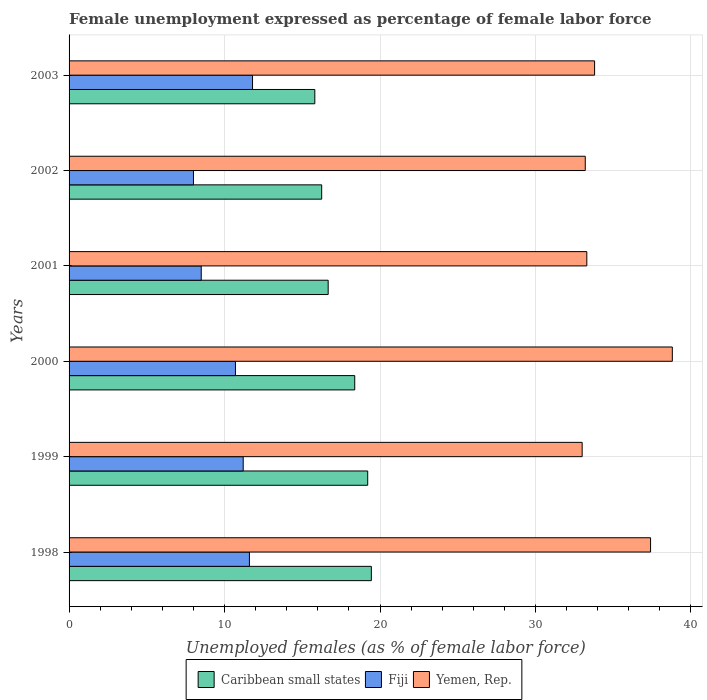How many different coloured bars are there?
Your answer should be compact. 3. How many groups of bars are there?
Provide a succinct answer. 6. Are the number of bars on each tick of the Y-axis equal?
Provide a short and direct response. Yes. In how many cases, is the number of bars for a given year not equal to the number of legend labels?
Offer a very short reply. 0. What is the unemployment in females in in Fiji in 2003?
Your answer should be very brief. 11.8. Across all years, what is the maximum unemployment in females in in Caribbean small states?
Offer a very short reply. 19.44. Across all years, what is the minimum unemployment in females in in Fiji?
Your answer should be compact. 8. In which year was the unemployment in females in in Fiji maximum?
Make the answer very short. 2003. What is the total unemployment in females in in Caribbean small states in the graph?
Your answer should be very brief. 105.74. What is the difference between the unemployment in females in in Yemen, Rep. in 1998 and that in 2003?
Your response must be concise. 3.6. What is the difference between the unemployment in females in in Yemen, Rep. in 1998 and the unemployment in females in in Fiji in 2003?
Offer a very short reply. 25.6. What is the average unemployment in females in in Yemen, Rep. per year?
Ensure brevity in your answer.  34.92. In the year 2000, what is the difference between the unemployment in females in in Caribbean small states and unemployment in females in in Fiji?
Your response must be concise. 7.67. In how many years, is the unemployment in females in in Fiji greater than 18 %?
Keep it short and to the point. 0. What is the ratio of the unemployment in females in in Fiji in 1999 to that in 2003?
Your answer should be very brief. 0.95. Is the unemployment in females in in Fiji in 2002 less than that in 2003?
Provide a succinct answer. Yes. What is the difference between the highest and the second highest unemployment in females in in Yemen, Rep.?
Your answer should be very brief. 1.4. What is the difference between the highest and the lowest unemployment in females in in Fiji?
Offer a very short reply. 3.8. Is the sum of the unemployment in females in in Fiji in 2001 and 2003 greater than the maximum unemployment in females in in Caribbean small states across all years?
Your answer should be very brief. Yes. What does the 3rd bar from the top in 2001 represents?
Keep it short and to the point. Caribbean small states. What does the 3rd bar from the bottom in 2002 represents?
Ensure brevity in your answer.  Yemen, Rep. Is it the case that in every year, the sum of the unemployment in females in in Caribbean small states and unemployment in females in in Fiji is greater than the unemployment in females in in Yemen, Rep.?
Provide a succinct answer. No. Are all the bars in the graph horizontal?
Ensure brevity in your answer.  Yes. What is the difference between two consecutive major ticks on the X-axis?
Make the answer very short. 10. Are the values on the major ticks of X-axis written in scientific E-notation?
Ensure brevity in your answer.  No. Does the graph contain grids?
Your answer should be compact. Yes. Where does the legend appear in the graph?
Your response must be concise. Bottom center. How many legend labels are there?
Offer a terse response. 3. What is the title of the graph?
Provide a succinct answer. Female unemployment expressed as percentage of female labor force. Does "Azerbaijan" appear as one of the legend labels in the graph?
Ensure brevity in your answer.  No. What is the label or title of the X-axis?
Offer a very short reply. Unemployed females (as % of female labor force). What is the label or title of the Y-axis?
Provide a succinct answer. Years. What is the Unemployed females (as % of female labor force) in Caribbean small states in 1998?
Make the answer very short. 19.44. What is the Unemployed females (as % of female labor force) of Fiji in 1998?
Make the answer very short. 11.6. What is the Unemployed females (as % of female labor force) in Yemen, Rep. in 1998?
Give a very brief answer. 37.4. What is the Unemployed females (as % of female labor force) in Caribbean small states in 1999?
Provide a succinct answer. 19.21. What is the Unemployed females (as % of female labor force) of Fiji in 1999?
Your answer should be compact. 11.2. What is the Unemployed females (as % of female labor force) in Yemen, Rep. in 1999?
Make the answer very short. 33. What is the Unemployed females (as % of female labor force) in Caribbean small states in 2000?
Provide a short and direct response. 18.37. What is the Unemployed females (as % of female labor force) of Fiji in 2000?
Offer a very short reply. 10.7. What is the Unemployed females (as % of female labor force) of Yemen, Rep. in 2000?
Your answer should be very brief. 38.8. What is the Unemployed females (as % of female labor force) of Caribbean small states in 2001?
Keep it short and to the point. 16.66. What is the Unemployed females (as % of female labor force) of Fiji in 2001?
Give a very brief answer. 8.5. What is the Unemployed females (as % of female labor force) in Yemen, Rep. in 2001?
Make the answer very short. 33.3. What is the Unemployed females (as % of female labor force) of Caribbean small states in 2002?
Keep it short and to the point. 16.25. What is the Unemployed females (as % of female labor force) in Fiji in 2002?
Your answer should be compact. 8. What is the Unemployed females (as % of female labor force) of Yemen, Rep. in 2002?
Your answer should be very brief. 33.2. What is the Unemployed females (as % of female labor force) of Caribbean small states in 2003?
Offer a very short reply. 15.81. What is the Unemployed females (as % of female labor force) in Fiji in 2003?
Your answer should be compact. 11.8. What is the Unemployed females (as % of female labor force) in Yemen, Rep. in 2003?
Give a very brief answer. 33.8. Across all years, what is the maximum Unemployed females (as % of female labor force) in Caribbean small states?
Make the answer very short. 19.44. Across all years, what is the maximum Unemployed females (as % of female labor force) in Fiji?
Offer a terse response. 11.8. Across all years, what is the maximum Unemployed females (as % of female labor force) in Yemen, Rep.?
Make the answer very short. 38.8. Across all years, what is the minimum Unemployed females (as % of female labor force) in Caribbean small states?
Your answer should be very brief. 15.81. Across all years, what is the minimum Unemployed females (as % of female labor force) of Fiji?
Keep it short and to the point. 8. Across all years, what is the minimum Unemployed females (as % of female labor force) of Yemen, Rep.?
Your response must be concise. 33. What is the total Unemployed females (as % of female labor force) of Caribbean small states in the graph?
Your answer should be very brief. 105.74. What is the total Unemployed females (as % of female labor force) in Fiji in the graph?
Your answer should be very brief. 61.8. What is the total Unemployed females (as % of female labor force) in Yemen, Rep. in the graph?
Provide a short and direct response. 209.5. What is the difference between the Unemployed females (as % of female labor force) of Caribbean small states in 1998 and that in 1999?
Offer a very short reply. 0.23. What is the difference between the Unemployed females (as % of female labor force) of Fiji in 1998 and that in 1999?
Offer a very short reply. 0.4. What is the difference between the Unemployed females (as % of female labor force) of Caribbean small states in 1998 and that in 2000?
Your answer should be compact. 1.07. What is the difference between the Unemployed females (as % of female labor force) of Fiji in 1998 and that in 2000?
Your response must be concise. 0.9. What is the difference between the Unemployed females (as % of female labor force) in Caribbean small states in 1998 and that in 2001?
Offer a terse response. 2.78. What is the difference between the Unemployed females (as % of female labor force) of Yemen, Rep. in 1998 and that in 2001?
Offer a terse response. 4.1. What is the difference between the Unemployed females (as % of female labor force) in Caribbean small states in 1998 and that in 2002?
Your response must be concise. 3.19. What is the difference between the Unemployed females (as % of female labor force) in Yemen, Rep. in 1998 and that in 2002?
Ensure brevity in your answer.  4.2. What is the difference between the Unemployed females (as % of female labor force) in Caribbean small states in 1998 and that in 2003?
Offer a terse response. 3.64. What is the difference between the Unemployed females (as % of female labor force) of Caribbean small states in 1999 and that in 2000?
Keep it short and to the point. 0.83. What is the difference between the Unemployed females (as % of female labor force) of Fiji in 1999 and that in 2000?
Make the answer very short. 0.5. What is the difference between the Unemployed females (as % of female labor force) in Caribbean small states in 1999 and that in 2001?
Keep it short and to the point. 2.54. What is the difference between the Unemployed females (as % of female labor force) in Yemen, Rep. in 1999 and that in 2001?
Provide a succinct answer. -0.3. What is the difference between the Unemployed females (as % of female labor force) in Caribbean small states in 1999 and that in 2002?
Offer a very short reply. 2.96. What is the difference between the Unemployed females (as % of female labor force) of Caribbean small states in 1999 and that in 2003?
Your response must be concise. 3.4. What is the difference between the Unemployed females (as % of female labor force) of Caribbean small states in 2000 and that in 2001?
Ensure brevity in your answer.  1.71. What is the difference between the Unemployed females (as % of female labor force) in Caribbean small states in 2000 and that in 2002?
Keep it short and to the point. 2.13. What is the difference between the Unemployed females (as % of female labor force) in Caribbean small states in 2000 and that in 2003?
Your answer should be compact. 2.57. What is the difference between the Unemployed females (as % of female labor force) in Yemen, Rep. in 2000 and that in 2003?
Your response must be concise. 5. What is the difference between the Unemployed females (as % of female labor force) of Caribbean small states in 2001 and that in 2002?
Ensure brevity in your answer.  0.42. What is the difference between the Unemployed females (as % of female labor force) in Yemen, Rep. in 2001 and that in 2002?
Keep it short and to the point. 0.1. What is the difference between the Unemployed females (as % of female labor force) in Caribbean small states in 2001 and that in 2003?
Keep it short and to the point. 0.86. What is the difference between the Unemployed females (as % of female labor force) in Fiji in 2001 and that in 2003?
Offer a terse response. -3.3. What is the difference between the Unemployed females (as % of female labor force) of Caribbean small states in 2002 and that in 2003?
Give a very brief answer. 0.44. What is the difference between the Unemployed females (as % of female labor force) of Caribbean small states in 1998 and the Unemployed females (as % of female labor force) of Fiji in 1999?
Provide a succinct answer. 8.24. What is the difference between the Unemployed females (as % of female labor force) in Caribbean small states in 1998 and the Unemployed females (as % of female labor force) in Yemen, Rep. in 1999?
Your response must be concise. -13.56. What is the difference between the Unemployed females (as % of female labor force) of Fiji in 1998 and the Unemployed females (as % of female labor force) of Yemen, Rep. in 1999?
Provide a succinct answer. -21.4. What is the difference between the Unemployed females (as % of female labor force) in Caribbean small states in 1998 and the Unemployed females (as % of female labor force) in Fiji in 2000?
Offer a very short reply. 8.74. What is the difference between the Unemployed females (as % of female labor force) in Caribbean small states in 1998 and the Unemployed females (as % of female labor force) in Yemen, Rep. in 2000?
Keep it short and to the point. -19.36. What is the difference between the Unemployed females (as % of female labor force) of Fiji in 1998 and the Unemployed females (as % of female labor force) of Yemen, Rep. in 2000?
Your answer should be very brief. -27.2. What is the difference between the Unemployed females (as % of female labor force) of Caribbean small states in 1998 and the Unemployed females (as % of female labor force) of Fiji in 2001?
Your response must be concise. 10.94. What is the difference between the Unemployed females (as % of female labor force) in Caribbean small states in 1998 and the Unemployed females (as % of female labor force) in Yemen, Rep. in 2001?
Your answer should be very brief. -13.86. What is the difference between the Unemployed females (as % of female labor force) of Fiji in 1998 and the Unemployed females (as % of female labor force) of Yemen, Rep. in 2001?
Make the answer very short. -21.7. What is the difference between the Unemployed females (as % of female labor force) of Caribbean small states in 1998 and the Unemployed females (as % of female labor force) of Fiji in 2002?
Provide a succinct answer. 11.44. What is the difference between the Unemployed females (as % of female labor force) in Caribbean small states in 1998 and the Unemployed females (as % of female labor force) in Yemen, Rep. in 2002?
Offer a very short reply. -13.76. What is the difference between the Unemployed females (as % of female labor force) in Fiji in 1998 and the Unemployed females (as % of female labor force) in Yemen, Rep. in 2002?
Give a very brief answer. -21.6. What is the difference between the Unemployed females (as % of female labor force) in Caribbean small states in 1998 and the Unemployed females (as % of female labor force) in Fiji in 2003?
Provide a short and direct response. 7.64. What is the difference between the Unemployed females (as % of female labor force) of Caribbean small states in 1998 and the Unemployed females (as % of female labor force) of Yemen, Rep. in 2003?
Provide a short and direct response. -14.36. What is the difference between the Unemployed females (as % of female labor force) of Fiji in 1998 and the Unemployed females (as % of female labor force) of Yemen, Rep. in 2003?
Give a very brief answer. -22.2. What is the difference between the Unemployed females (as % of female labor force) of Caribbean small states in 1999 and the Unemployed females (as % of female labor force) of Fiji in 2000?
Provide a short and direct response. 8.51. What is the difference between the Unemployed females (as % of female labor force) of Caribbean small states in 1999 and the Unemployed females (as % of female labor force) of Yemen, Rep. in 2000?
Ensure brevity in your answer.  -19.59. What is the difference between the Unemployed females (as % of female labor force) of Fiji in 1999 and the Unemployed females (as % of female labor force) of Yemen, Rep. in 2000?
Ensure brevity in your answer.  -27.6. What is the difference between the Unemployed females (as % of female labor force) in Caribbean small states in 1999 and the Unemployed females (as % of female labor force) in Fiji in 2001?
Ensure brevity in your answer.  10.71. What is the difference between the Unemployed females (as % of female labor force) of Caribbean small states in 1999 and the Unemployed females (as % of female labor force) of Yemen, Rep. in 2001?
Your response must be concise. -14.09. What is the difference between the Unemployed females (as % of female labor force) of Fiji in 1999 and the Unemployed females (as % of female labor force) of Yemen, Rep. in 2001?
Offer a terse response. -22.1. What is the difference between the Unemployed females (as % of female labor force) of Caribbean small states in 1999 and the Unemployed females (as % of female labor force) of Fiji in 2002?
Give a very brief answer. 11.21. What is the difference between the Unemployed females (as % of female labor force) of Caribbean small states in 1999 and the Unemployed females (as % of female labor force) of Yemen, Rep. in 2002?
Make the answer very short. -13.99. What is the difference between the Unemployed females (as % of female labor force) in Fiji in 1999 and the Unemployed females (as % of female labor force) in Yemen, Rep. in 2002?
Give a very brief answer. -22. What is the difference between the Unemployed females (as % of female labor force) in Caribbean small states in 1999 and the Unemployed females (as % of female labor force) in Fiji in 2003?
Your answer should be compact. 7.41. What is the difference between the Unemployed females (as % of female labor force) of Caribbean small states in 1999 and the Unemployed females (as % of female labor force) of Yemen, Rep. in 2003?
Your answer should be compact. -14.59. What is the difference between the Unemployed females (as % of female labor force) in Fiji in 1999 and the Unemployed females (as % of female labor force) in Yemen, Rep. in 2003?
Your answer should be compact. -22.6. What is the difference between the Unemployed females (as % of female labor force) of Caribbean small states in 2000 and the Unemployed females (as % of female labor force) of Fiji in 2001?
Offer a very short reply. 9.87. What is the difference between the Unemployed females (as % of female labor force) in Caribbean small states in 2000 and the Unemployed females (as % of female labor force) in Yemen, Rep. in 2001?
Your response must be concise. -14.93. What is the difference between the Unemployed females (as % of female labor force) in Fiji in 2000 and the Unemployed females (as % of female labor force) in Yemen, Rep. in 2001?
Provide a short and direct response. -22.6. What is the difference between the Unemployed females (as % of female labor force) of Caribbean small states in 2000 and the Unemployed females (as % of female labor force) of Fiji in 2002?
Provide a succinct answer. 10.37. What is the difference between the Unemployed females (as % of female labor force) of Caribbean small states in 2000 and the Unemployed females (as % of female labor force) of Yemen, Rep. in 2002?
Keep it short and to the point. -14.83. What is the difference between the Unemployed females (as % of female labor force) of Fiji in 2000 and the Unemployed females (as % of female labor force) of Yemen, Rep. in 2002?
Make the answer very short. -22.5. What is the difference between the Unemployed females (as % of female labor force) in Caribbean small states in 2000 and the Unemployed females (as % of female labor force) in Fiji in 2003?
Your answer should be very brief. 6.57. What is the difference between the Unemployed females (as % of female labor force) of Caribbean small states in 2000 and the Unemployed females (as % of female labor force) of Yemen, Rep. in 2003?
Give a very brief answer. -15.43. What is the difference between the Unemployed females (as % of female labor force) of Fiji in 2000 and the Unemployed females (as % of female labor force) of Yemen, Rep. in 2003?
Your response must be concise. -23.1. What is the difference between the Unemployed females (as % of female labor force) of Caribbean small states in 2001 and the Unemployed females (as % of female labor force) of Fiji in 2002?
Make the answer very short. 8.66. What is the difference between the Unemployed females (as % of female labor force) in Caribbean small states in 2001 and the Unemployed females (as % of female labor force) in Yemen, Rep. in 2002?
Offer a very short reply. -16.54. What is the difference between the Unemployed females (as % of female labor force) of Fiji in 2001 and the Unemployed females (as % of female labor force) of Yemen, Rep. in 2002?
Your answer should be very brief. -24.7. What is the difference between the Unemployed females (as % of female labor force) of Caribbean small states in 2001 and the Unemployed females (as % of female labor force) of Fiji in 2003?
Your response must be concise. 4.86. What is the difference between the Unemployed females (as % of female labor force) in Caribbean small states in 2001 and the Unemployed females (as % of female labor force) in Yemen, Rep. in 2003?
Your response must be concise. -17.14. What is the difference between the Unemployed females (as % of female labor force) in Fiji in 2001 and the Unemployed females (as % of female labor force) in Yemen, Rep. in 2003?
Offer a very short reply. -25.3. What is the difference between the Unemployed females (as % of female labor force) of Caribbean small states in 2002 and the Unemployed females (as % of female labor force) of Fiji in 2003?
Provide a short and direct response. 4.45. What is the difference between the Unemployed females (as % of female labor force) in Caribbean small states in 2002 and the Unemployed females (as % of female labor force) in Yemen, Rep. in 2003?
Your response must be concise. -17.55. What is the difference between the Unemployed females (as % of female labor force) of Fiji in 2002 and the Unemployed females (as % of female labor force) of Yemen, Rep. in 2003?
Ensure brevity in your answer.  -25.8. What is the average Unemployed females (as % of female labor force) of Caribbean small states per year?
Ensure brevity in your answer.  17.62. What is the average Unemployed females (as % of female labor force) in Yemen, Rep. per year?
Your answer should be compact. 34.92. In the year 1998, what is the difference between the Unemployed females (as % of female labor force) of Caribbean small states and Unemployed females (as % of female labor force) of Fiji?
Provide a short and direct response. 7.84. In the year 1998, what is the difference between the Unemployed females (as % of female labor force) in Caribbean small states and Unemployed females (as % of female labor force) in Yemen, Rep.?
Offer a very short reply. -17.96. In the year 1998, what is the difference between the Unemployed females (as % of female labor force) in Fiji and Unemployed females (as % of female labor force) in Yemen, Rep.?
Provide a short and direct response. -25.8. In the year 1999, what is the difference between the Unemployed females (as % of female labor force) in Caribbean small states and Unemployed females (as % of female labor force) in Fiji?
Keep it short and to the point. 8.01. In the year 1999, what is the difference between the Unemployed females (as % of female labor force) in Caribbean small states and Unemployed females (as % of female labor force) in Yemen, Rep.?
Ensure brevity in your answer.  -13.79. In the year 1999, what is the difference between the Unemployed females (as % of female labor force) in Fiji and Unemployed females (as % of female labor force) in Yemen, Rep.?
Your answer should be compact. -21.8. In the year 2000, what is the difference between the Unemployed females (as % of female labor force) in Caribbean small states and Unemployed females (as % of female labor force) in Fiji?
Give a very brief answer. 7.67. In the year 2000, what is the difference between the Unemployed females (as % of female labor force) in Caribbean small states and Unemployed females (as % of female labor force) in Yemen, Rep.?
Provide a succinct answer. -20.43. In the year 2000, what is the difference between the Unemployed females (as % of female labor force) of Fiji and Unemployed females (as % of female labor force) of Yemen, Rep.?
Provide a short and direct response. -28.1. In the year 2001, what is the difference between the Unemployed females (as % of female labor force) in Caribbean small states and Unemployed females (as % of female labor force) in Fiji?
Your response must be concise. 8.16. In the year 2001, what is the difference between the Unemployed females (as % of female labor force) in Caribbean small states and Unemployed females (as % of female labor force) in Yemen, Rep.?
Your response must be concise. -16.64. In the year 2001, what is the difference between the Unemployed females (as % of female labor force) in Fiji and Unemployed females (as % of female labor force) in Yemen, Rep.?
Provide a succinct answer. -24.8. In the year 2002, what is the difference between the Unemployed females (as % of female labor force) of Caribbean small states and Unemployed females (as % of female labor force) of Fiji?
Your answer should be very brief. 8.25. In the year 2002, what is the difference between the Unemployed females (as % of female labor force) in Caribbean small states and Unemployed females (as % of female labor force) in Yemen, Rep.?
Your answer should be very brief. -16.95. In the year 2002, what is the difference between the Unemployed females (as % of female labor force) in Fiji and Unemployed females (as % of female labor force) in Yemen, Rep.?
Make the answer very short. -25.2. In the year 2003, what is the difference between the Unemployed females (as % of female labor force) in Caribbean small states and Unemployed females (as % of female labor force) in Fiji?
Your answer should be very brief. 4.01. In the year 2003, what is the difference between the Unemployed females (as % of female labor force) of Caribbean small states and Unemployed females (as % of female labor force) of Yemen, Rep.?
Offer a very short reply. -17.99. What is the ratio of the Unemployed females (as % of female labor force) of Caribbean small states in 1998 to that in 1999?
Keep it short and to the point. 1.01. What is the ratio of the Unemployed females (as % of female labor force) of Fiji in 1998 to that in 1999?
Offer a terse response. 1.04. What is the ratio of the Unemployed females (as % of female labor force) of Yemen, Rep. in 1998 to that in 1999?
Give a very brief answer. 1.13. What is the ratio of the Unemployed females (as % of female labor force) of Caribbean small states in 1998 to that in 2000?
Give a very brief answer. 1.06. What is the ratio of the Unemployed females (as % of female labor force) of Fiji in 1998 to that in 2000?
Your answer should be very brief. 1.08. What is the ratio of the Unemployed females (as % of female labor force) in Yemen, Rep. in 1998 to that in 2000?
Keep it short and to the point. 0.96. What is the ratio of the Unemployed females (as % of female labor force) of Caribbean small states in 1998 to that in 2001?
Your response must be concise. 1.17. What is the ratio of the Unemployed females (as % of female labor force) in Fiji in 1998 to that in 2001?
Your response must be concise. 1.36. What is the ratio of the Unemployed females (as % of female labor force) of Yemen, Rep. in 1998 to that in 2001?
Offer a terse response. 1.12. What is the ratio of the Unemployed females (as % of female labor force) in Caribbean small states in 1998 to that in 2002?
Provide a short and direct response. 1.2. What is the ratio of the Unemployed females (as % of female labor force) of Fiji in 1998 to that in 2002?
Make the answer very short. 1.45. What is the ratio of the Unemployed females (as % of female labor force) of Yemen, Rep. in 1998 to that in 2002?
Provide a short and direct response. 1.13. What is the ratio of the Unemployed females (as % of female labor force) in Caribbean small states in 1998 to that in 2003?
Provide a succinct answer. 1.23. What is the ratio of the Unemployed females (as % of female labor force) in Fiji in 1998 to that in 2003?
Keep it short and to the point. 0.98. What is the ratio of the Unemployed females (as % of female labor force) in Yemen, Rep. in 1998 to that in 2003?
Your answer should be compact. 1.11. What is the ratio of the Unemployed females (as % of female labor force) of Caribbean small states in 1999 to that in 2000?
Offer a very short reply. 1.05. What is the ratio of the Unemployed females (as % of female labor force) of Fiji in 1999 to that in 2000?
Give a very brief answer. 1.05. What is the ratio of the Unemployed females (as % of female labor force) in Yemen, Rep. in 1999 to that in 2000?
Provide a short and direct response. 0.85. What is the ratio of the Unemployed females (as % of female labor force) of Caribbean small states in 1999 to that in 2001?
Your answer should be very brief. 1.15. What is the ratio of the Unemployed females (as % of female labor force) in Fiji in 1999 to that in 2001?
Keep it short and to the point. 1.32. What is the ratio of the Unemployed females (as % of female labor force) in Yemen, Rep. in 1999 to that in 2001?
Your answer should be very brief. 0.99. What is the ratio of the Unemployed females (as % of female labor force) in Caribbean small states in 1999 to that in 2002?
Offer a terse response. 1.18. What is the ratio of the Unemployed females (as % of female labor force) of Yemen, Rep. in 1999 to that in 2002?
Provide a succinct answer. 0.99. What is the ratio of the Unemployed females (as % of female labor force) in Caribbean small states in 1999 to that in 2003?
Give a very brief answer. 1.22. What is the ratio of the Unemployed females (as % of female labor force) of Fiji in 1999 to that in 2003?
Ensure brevity in your answer.  0.95. What is the ratio of the Unemployed females (as % of female labor force) in Yemen, Rep. in 1999 to that in 2003?
Offer a very short reply. 0.98. What is the ratio of the Unemployed females (as % of female labor force) of Caribbean small states in 2000 to that in 2001?
Ensure brevity in your answer.  1.1. What is the ratio of the Unemployed females (as % of female labor force) in Fiji in 2000 to that in 2001?
Keep it short and to the point. 1.26. What is the ratio of the Unemployed females (as % of female labor force) of Yemen, Rep. in 2000 to that in 2001?
Your answer should be very brief. 1.17. What is the ratio of the Unemployed females (as % of female labor force) in Caribbean small states in 2000 to that in 2002?
Offer a very short reply. 1.13. What is the ratio of the Unemployed females (as % of female labor force) of Fiji in 2000 to that in 2002?
Offer a very short reply. 1.34. What is the ratio of the Unemployed females (as % of female labor force) in Yemen, Rep. in 2000 to that in 2002?
Give a very brief answer. 1.17. What is the ratio of the Unemployed females (as % of female labor force) in Caribbean small states in 2000 to that in 2003?
Keep it short and to the point. 1.16. What is the ratio of the Unemployed females (as % of female labor force) of Fiji in 2000 to that in 2003?
Give a very brief answer. 0.91. What is the ratio of the Unemployed females (as % of female labor force) in Yemen, Rep. in 2000 to that in 2003?
Keep it short and to the point. 1.15. What is the ratio of the Unemployed females (as % of female labor force) of Caribbean small states in 2001 to that in 2002?
Your answer should be very brief. 1.03. What is the ratio of the Unemployed females (as % of female labor force) in Fiji in 2001 to that in 2002?
Your answer should be very brief. 1.06. What is the ratio of the Unemployed females (as % of female labor force) in Caribbean small states in 2001 to that in 2003?
Your answer should be very brief. 1.05. What is the ratio of the Unemployed females (as % of female labor force) of Fiji in 2001 to that in 2003?
Your answer should be very brief. 0.72. What is the ratio of the Unemployed females (as % of female labor force) in Yemen, Rep. in 2001 to that in 2003?
Your response must be concise. 0.99. What is the ratio of the Unemployed females (as % of female labor force) of Caribbean small states in 2002 to that in 2003?
Keep it short and to the point. 1.03. What is the ratio of the Unemployed females (as % of female labor force) in Fiji in 2002 to that in 2003?
Offer a terse response. 0.68. What is the ratio of the Unemployed females (as % of female labor force) in Yemen, Rep. in 2002 to that in 2003?
Provide a short and direct response. 0.98. What is the difference between the highest and the second highest Unemployed females (as % of female labor force) of Caribbean small states?
Your response must be concise. 0.23. What is the difference between the highest and the second highest Unemployed females (as % of female labor force) of Fiji?
Your answer should be compact. 0.2. What is the difference between the highest and the second highest Unemployed females (as % of female labor force) of Yemen, Rep.?
Your answer should be compact. 1.4. What is the difference between the highest and the lowest Unemployed females (as % of female labor force) in Caribbean small states?
Provide a short and direct response. 3.64. What is the difference between the highest and the lowest Unemployed females (as % of female labor force) in Yemen, Rep.?
Give a very brief answer. 5.8. 